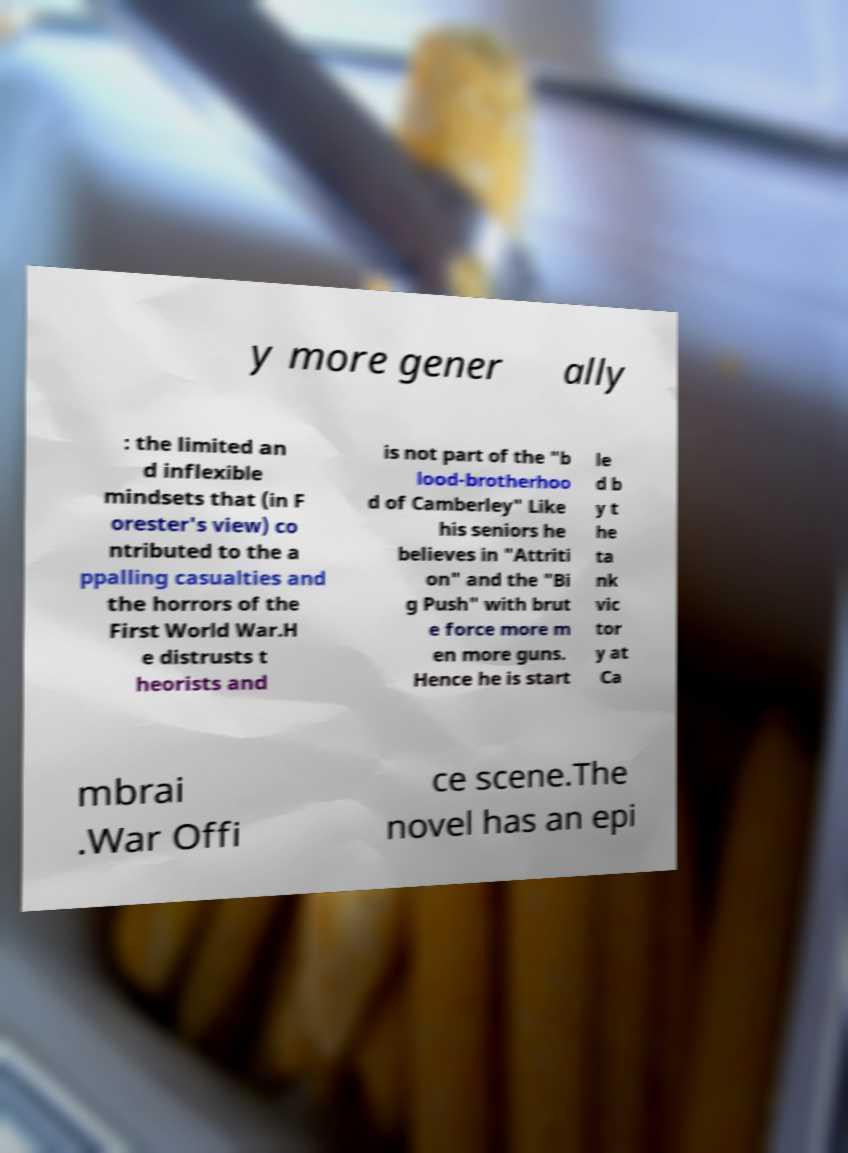Can you read and provide the text displayed in the image?This photo seems to have some interesting text. Can you extract and type it out for me? y more gener ally : the limited an d inflexible mindsets that (in F orester's view) co ntributed to the a ppalling casualties and the horrors of the First World War.H e distrusts t heorists and is not part of the "b lood-brotherhoo d of Camberley" Like his seniors he believes in "Attriti on" and the "Bi g Push" with brut e force more m en more guns. Hence he is start le d b y t he ta nk vic tor y at Ca mbrai .War Offi ce scene.The novel has an epi 